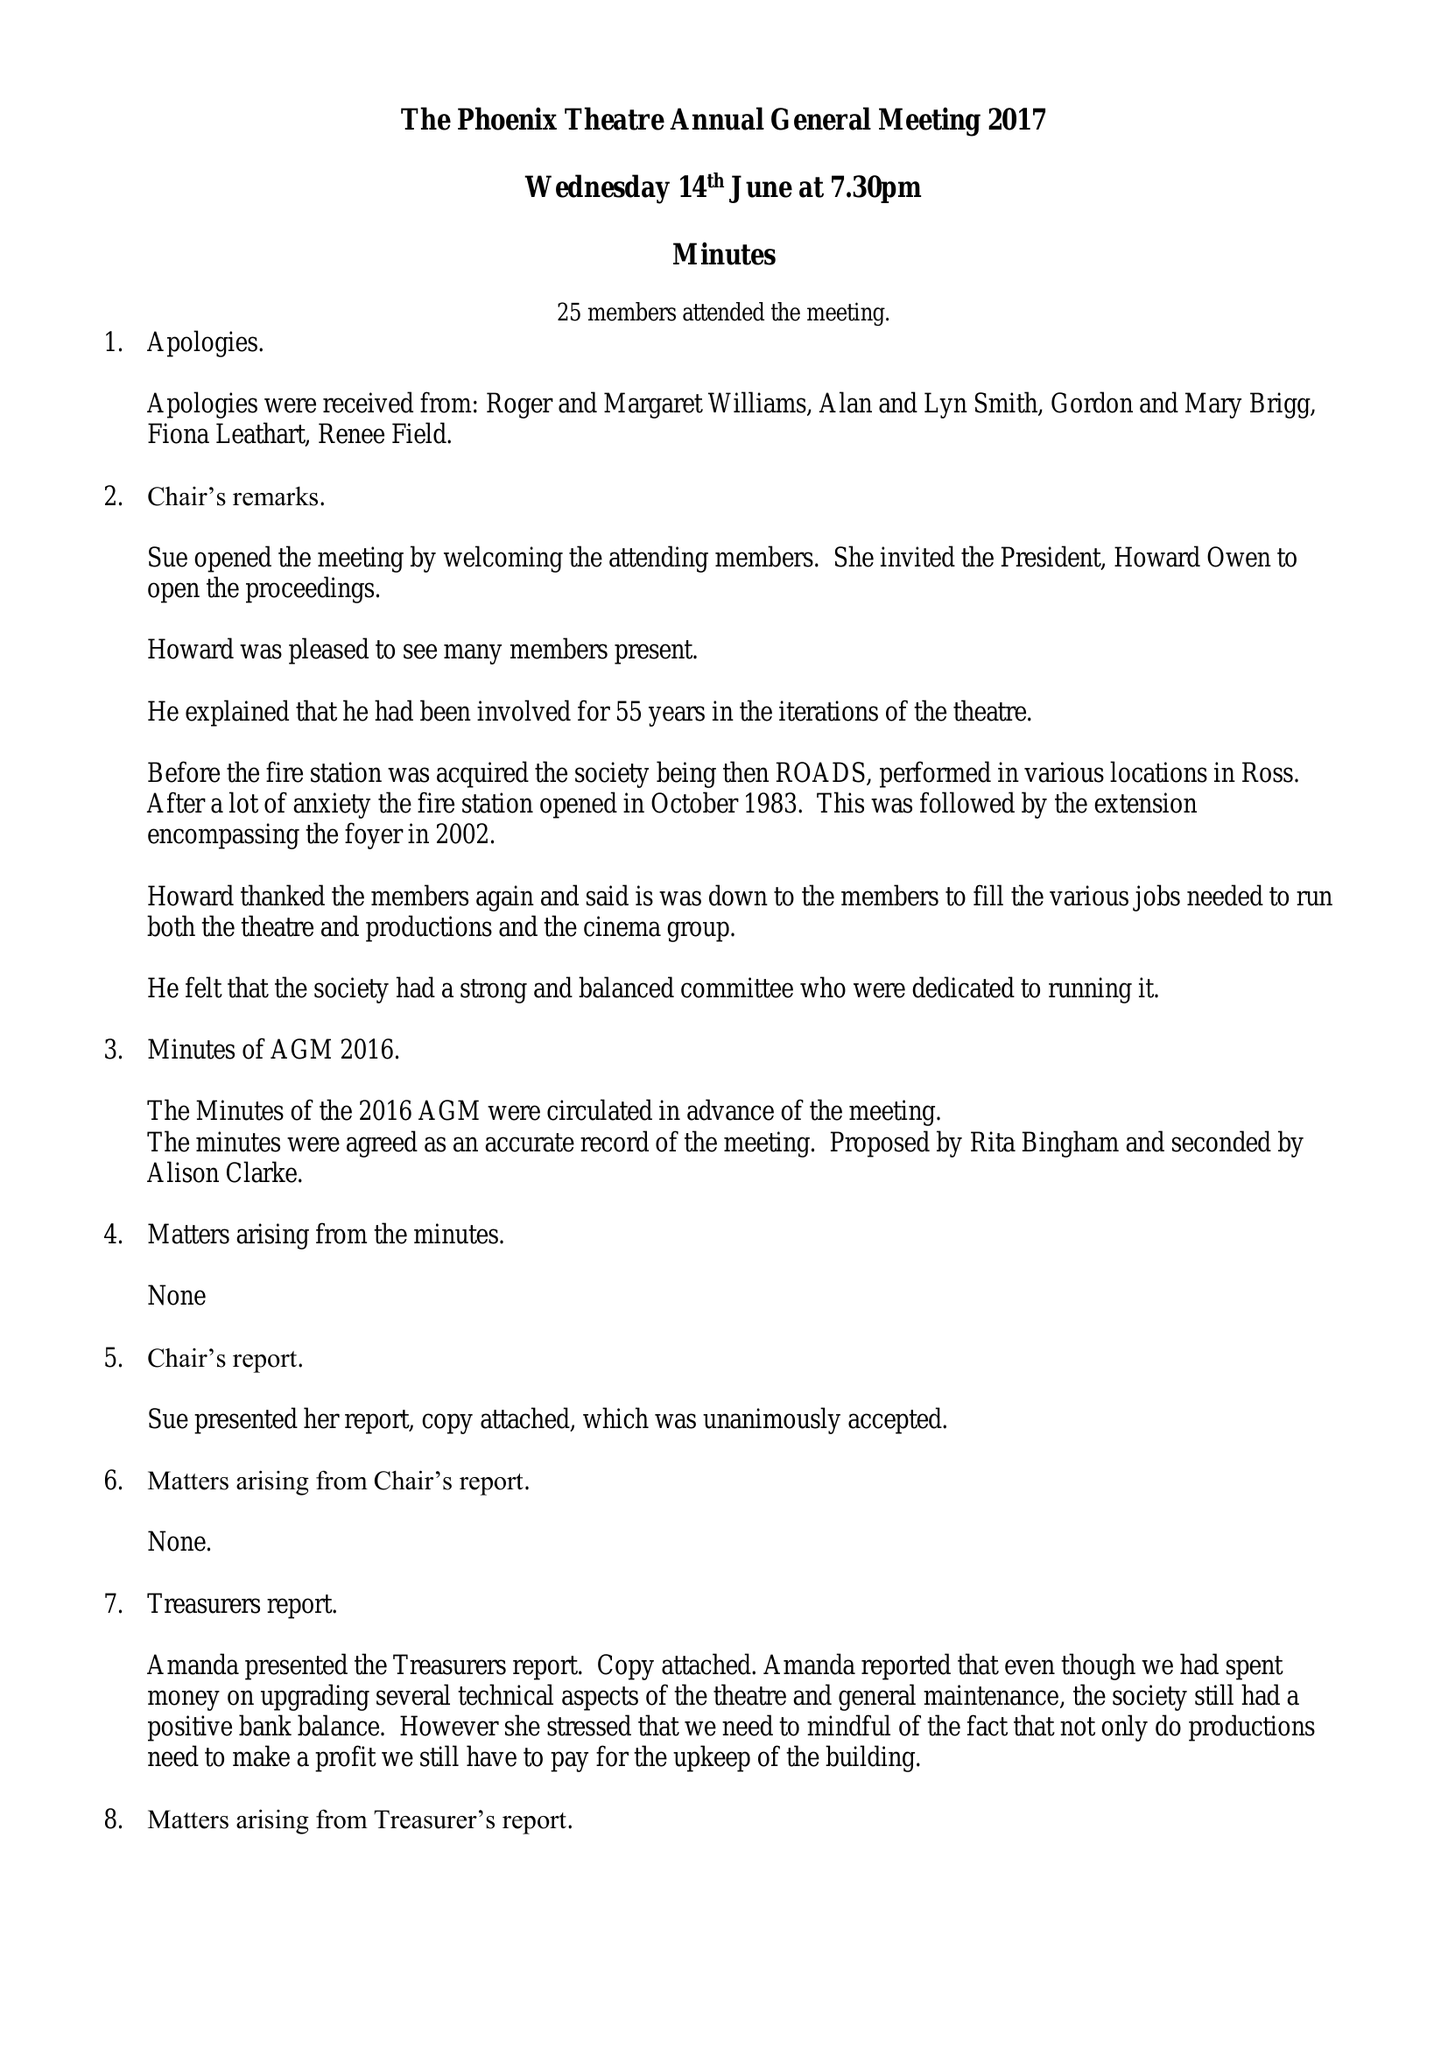What is the value for the address__postcode?
Answer the question using a single word or phrase. HR9 6QJ 